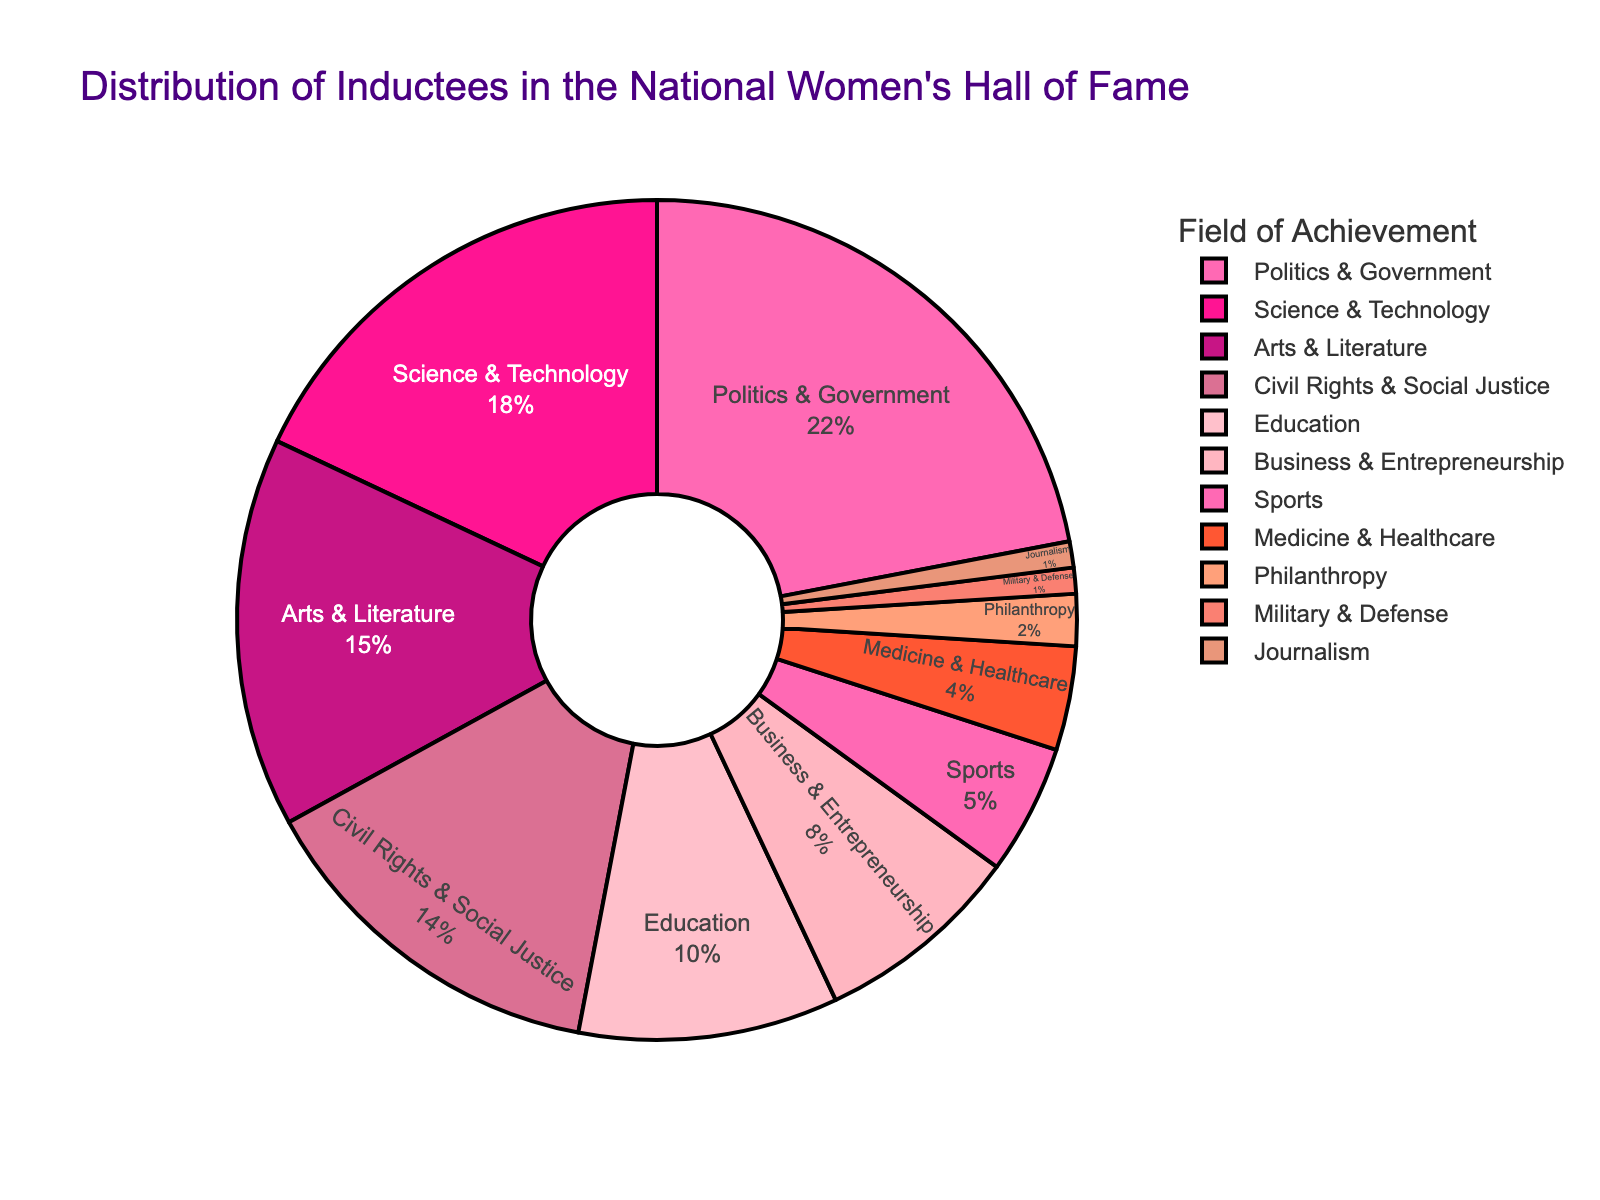Which field has the highest percentage of inductees? Locate the slice with the highest percentage label. The "Politics & Government" field has 22%, which is the highest percentage.
Answer: Politics & Government What is the total percentage of inductees in the fields of Science & Technology and Medicine & Healthcare? Add the percentages for "Science & Technology" (18%) and "Medicine & Healthcare" (4%). 18 + 4 = 22.
Answer: 22% Which field has a smaller percentage of inductees: Business & Entrepreneurship or Sports? Compare the percentages of "Business & Entrepreneurship" (8%) and "Sports" (5%). Sports have a smaller percentage.
Answer: Sports What is the combined percentage of inductees in the fields of Civil Rights & Social Justice, Education, and Journalism? Add the percentages for "Civil Rights & Social Justice" (14%), "Education" (10%), and "Journalism" (1%). 14 + 10 + 1 = 25.
Answer: 25% What is the difference in percentage between the fields with the largest and smallest representations? Subtract the smallest percentage (1% for both "Military & Defense" and "Journalism") from the largest percentage (22% for "Politics & Government"). 22 - 1 = 21.
Answer: 21% How does the percentage of inductees in Arts & Literature compare to those in Business & Entrepreneurship? Compare the percentages: "Arts & Literature" has 15% and "Business & Entrepreneurship" has 8%. The former is higher.
Answer: Arts & Literature is higher Which two fields have the same percentage of inductees? Look for fields with matching percentages. "Military & Defense" and "Journalism" both have 1%.
Answer: Military & Defense and Journalism What is the visual color used for the Education field? Identify the color attributed to the slice labeled "Education" in the pie chart. The color for "Education" is "#FFC0CB" which is a shade of pink.
Answer: Pink If a new inductee is added to the Military & Defense field, making the total 2%, what will be the new percentage for this field if the total number of inductees remains unchanged? Adding an inductee to "Military & Defense" changes its percentage from 1% to 2%. Since the total must remain 100%, reduce the other fields' percentages such that the sum remains 100%.
Answer: It will not stay 100% What fields make up more than 10% of the inductees? Identify fields with percentages greater than 10%. These are "Politics & Government" (22%), "Science & Technology" (18%), "Arts & Literature" (15%), and "Civil Rights & Social Justice" (14%).
Answer: Politics & Government, Science & Technology, Arts & Literature, Civil Rights & Social Justice 